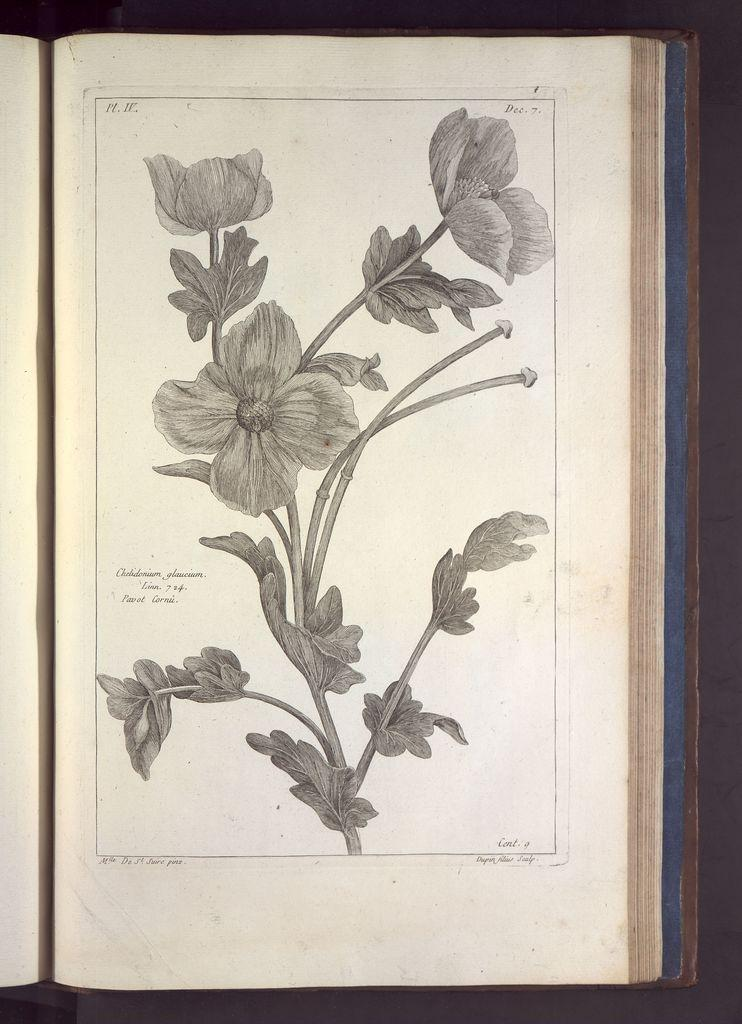What is the main subject of the book in the image? The book contains images of flowers, leaves, and plants. What type of content is included in the book? The book contains both images and text. What type of underwear is featured in the book's plot? There is no underwear or plot present in the book; it is a book about plants with images and text. 